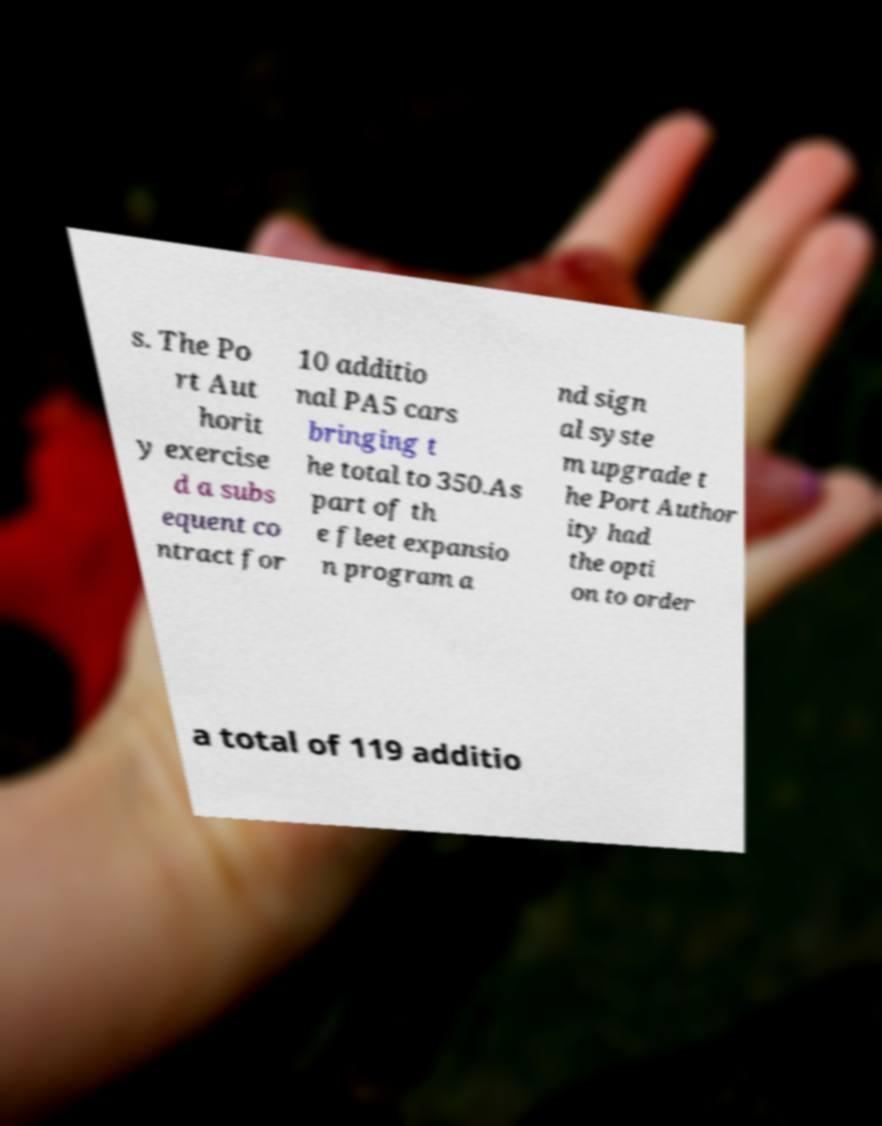There's text embedded in this image that I need extracted. Can you transcribe it verbatim? s. The Po rt Aut horit y exercise d a subs equent co ntract for 10 additio nal PA5 cars bringing t he total to 350.As part of th e fleet expansio n program a nd sign al syste m upgrade t he Port Author ity had the opti on to order a total of 119 additio 